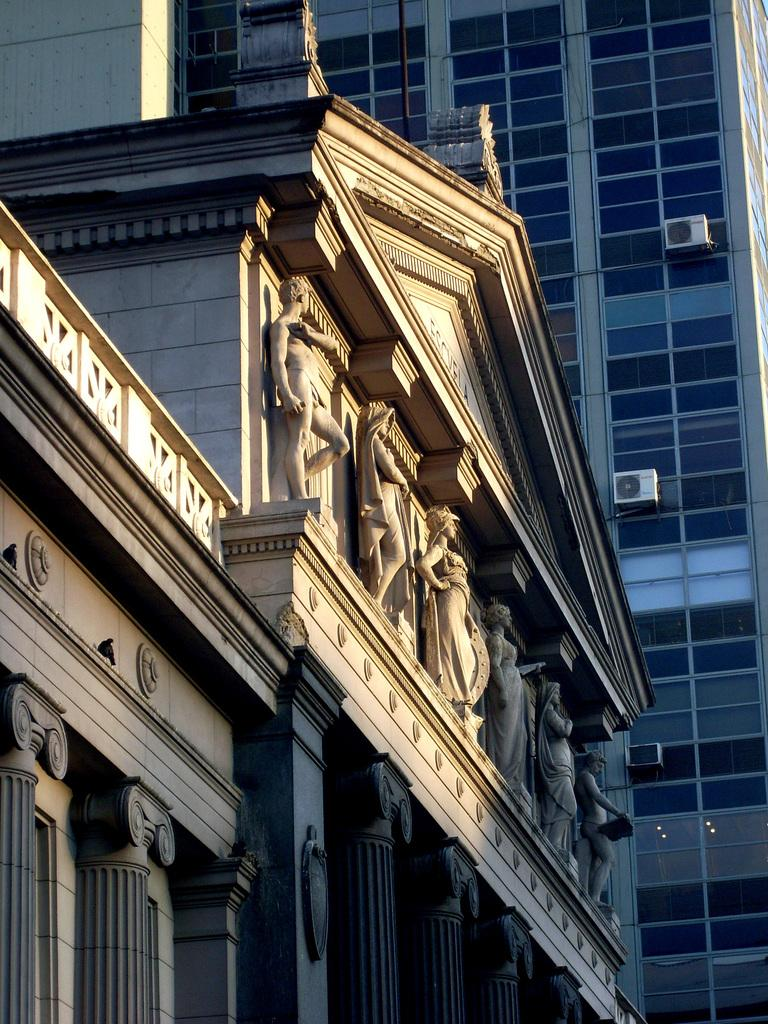What is the main subject of the image? The main subject of the image is many statues. How are the statues arranged in the image? The statues are placed one after the other. What architectural elements can be seen at the bottom of the image? There are pillars at the bottom of the image. What can be seen in the background of the image? There is a building in the background of the image. Can you tell me how many goats are standing next to the statues in the image? There are no goats present in the image; it features statues and architectural elements. 